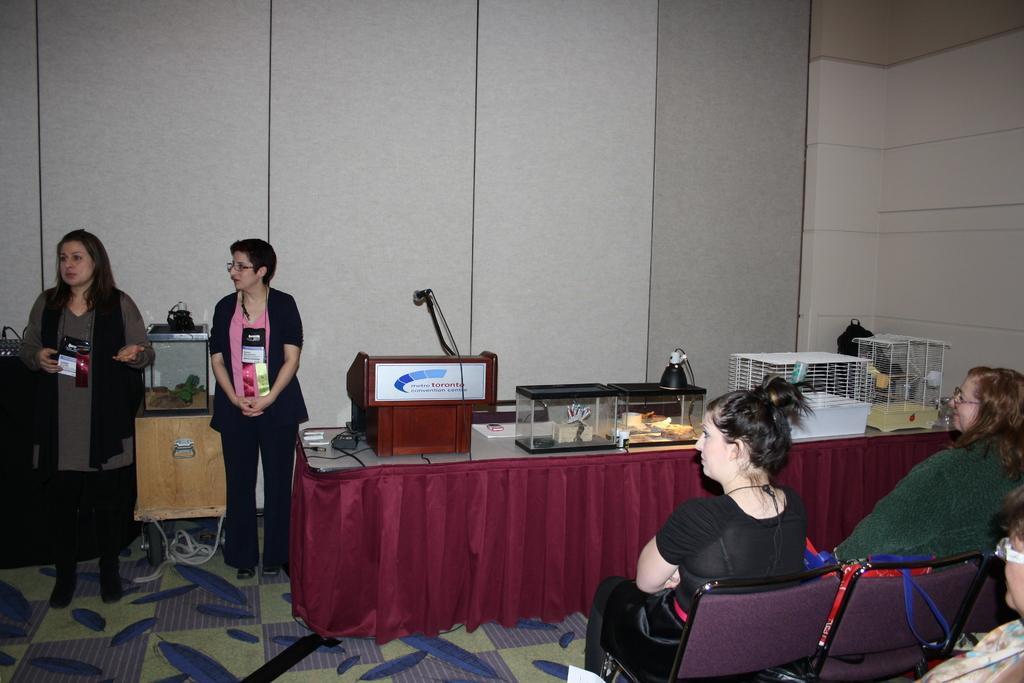Could you give a brief overview of what you see in this image? In the image there are two woman stood at left side and in the right side two woman sat on chairs and in the middle there is a table with glass bowls,boxes and cages and there is a mic podium near the wall , the floor has carpet on it. 